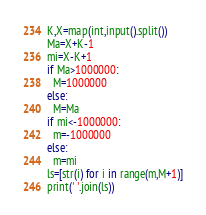<code> <loc_0><loc_0><loc_500><loc_500><_Python_>K,X=map(int,input().split())
Ma=X+K-1
mi=X-K+1
if Ma>1000000:
  M=1000000
else:
  M=Ma
if mi<-1000000:
  m=-1000000
else:
  m=mi
ls=[str(i) for i in range(m,M+1)]
print(' '.join(ls))</code> 